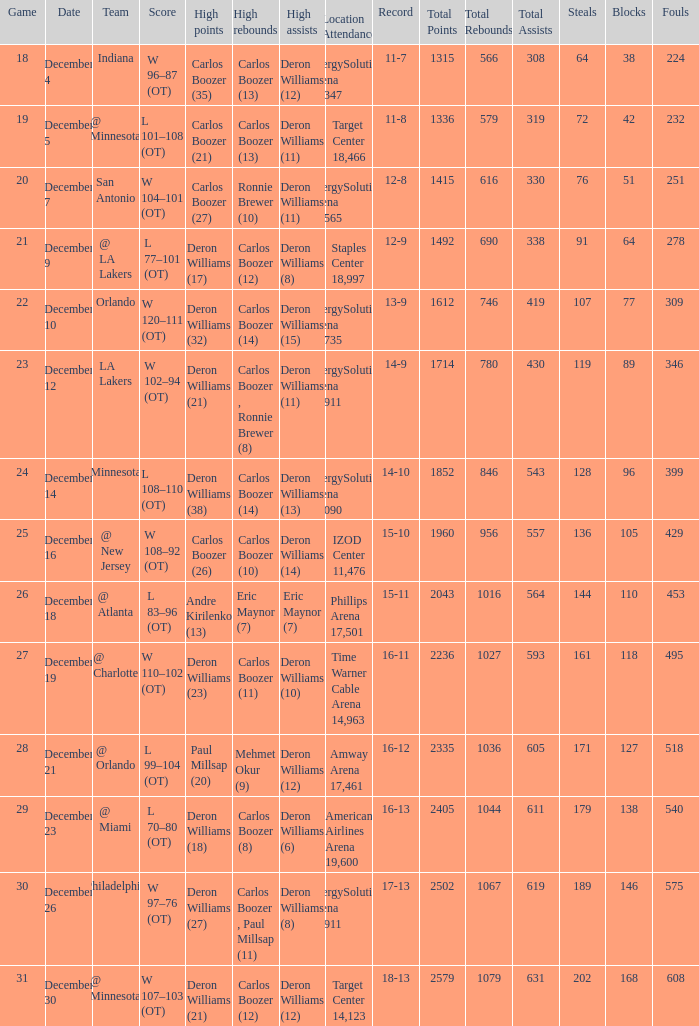What's the number of the game in which Carlos Boozer (8) did the high rebounds? 29.0. 